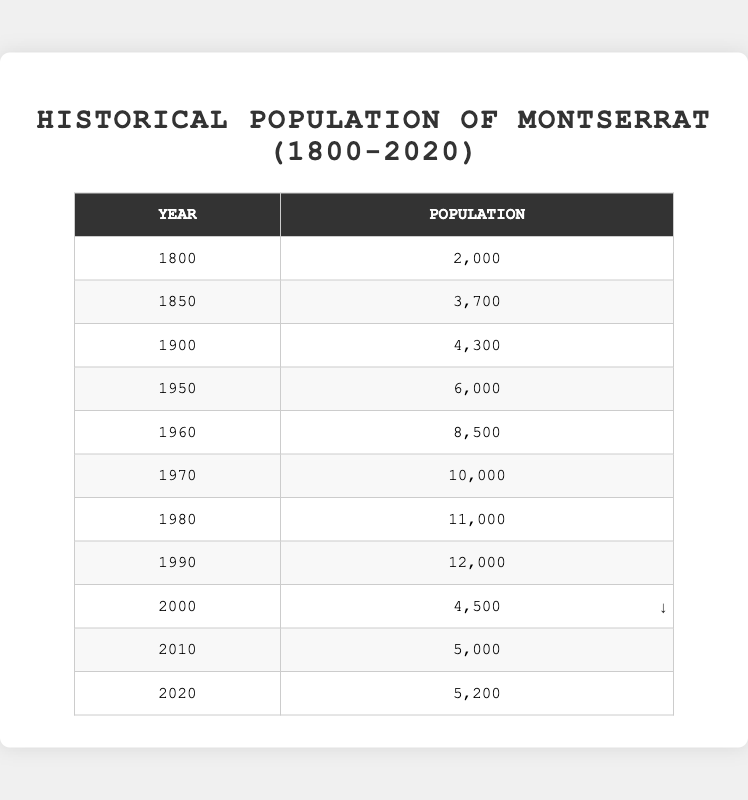What was the population of Montserrat in 1900? The table shows that in the year 1900, the population of Montserrat was 4,300.
Answer: 4,300 How many people lived in Montserrat in 1960 compared to 1950? According to the table, the population in 1960 was 8,500 and in 1950 it was 6,000. The difference is 8,500 - 6,000 = 2,500 more people in 1960.
Answer: 2,500 more What was the population of Montserrat in 2000 and 2010, and what was the change in population? The population in 2000 was 4,500 and in 2010 it was 5,000. The change is calculated as 5,000 - 4,500 = 500, meaning an increase of 500 people.
Answer: 500 Was there an increase in population from 1980 to 1990? The population in 1980 was 11,000, and in 1990 it was 12,000, indicating an increase since 12,000 is greater than 11,000.
Answer: Yes What is the average population of Montserrat from 1800 to 2020? To find the average, sum the populations for each year: (2,000 + 3,700 + 4,300 + 6,000 + 8,500 + 10,000 + 11,000 + 12,000 + 4,500 + 5,000 + 5,200) = 67,200. There are 11 data points, so the average is 67,200 / 11 = 6,118.18.
Answer: Approximately 6,118 What was the highest population recorded in the table and in which year? The highest population recorded was 12,000 in the year 1990, as indicated in the table.
Answer: 12,000 in 1990 From 1970 to 1990, how much did the population grow? The population in 1970 was 10,000, and in 1990 it was 12,000. The growth is 12,000 - 10,000 = 2,000.
Answer: 2,000 Was the population of Montserrat lower in 2010 than in 2000? In 2000, the population was 4,500, and in 2010 it was 5,000. Since 5,000 is greater than 4,500, the statement is false.
Answer: No How many years did Montserrat see a decrease in population, according to the data? The only year with a decrease in population was from 1990 (12,000) to 2000 (4,500). Therefore, there is just one instance of decline in this period.
Answer: 1 year What was the population trend from 1800 to 1970? The population increased consistently from 2,000 in 1800 to 10,000 in 1970, indicating a general upward trend over these years.
Answer: Increasing trend In which decade did Montserrat experience the largest drop in population? Comparing the values, the largest drop occurred between 1990 and 2000, where the population decreased from 12,000 to 4,500, a drop of 7,500.
Answer: 1990-2000 